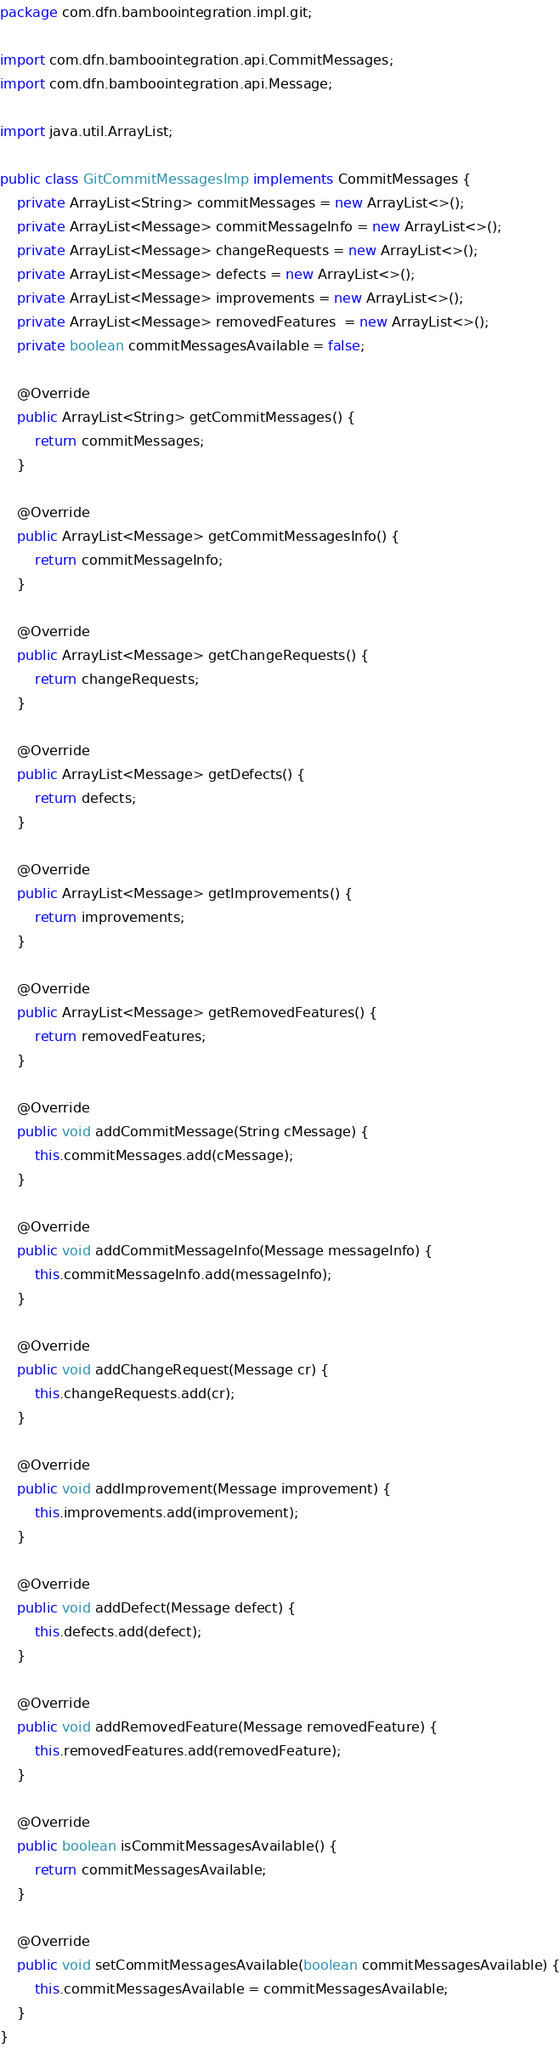Convert code to text. <code><loc_0><loc_0><loc_500><loc_500><_Java_>package com.dfn.bamboointegration.impl.git;

import com.dfn.bamboointegration.api.CommitMessages;
import com.dfn.bamboointegration.api.Message;

import java.util.ArrayList;

public class GitCommitMessagesImp implements CommitMessages {
    private ArrayList<String> commitMessages = new ArrayList<>();
    private ArrayList<Message> commitMessageInfo = new ArrayList<>();
    private ArrayList<Message> changeRequests = new ArrayList<>();
    private ArrayList<Message> defects = new ArrayList<>();
    private ArrayList<Message> improvements = new ArrayList<>();
    private ArrayList<Message> removedFeatures  = new ArrayList<>();
    private boolean commitMessagesAvailable = false;

    @Override
    public ArrayList<String> getCommitMessages() {
        return commitMessages;
    }

    @Override
    public ArrayList<Message> getCommitMessagesInfo() {
        return commitMessageInfo;
    }

    @Override
    public ArrayList<Message> getChangeRequests() {
        return changeRequests;
    }

    @Override
    public ArrayList<Message> getDefects() {
        return defects;
    }

    @Override
    public ArrayList<Message> getImprovements() {
        return improvements;
    }

    @Override
    public ArrayList<Message> getRemovedFeatures() {
        return removedFeatures;
    }

    @Override
    public void addCommitMessage(String cMessage) {
        this.commitMessages.add(cMessage);
    }

    @Override
    public void addCommitMessageInfo(Message messageInfo) {
        this.commitMessageInfo.add(messageInfo);
    }

    @Override
    public void addChangeRequest(Message cr) {
        this.changeRequests.add(cr);
    }

    @Override
    public void addImprovement(Message improvement) {
        this.improvements.add(improvement);
    }

    @Override
    public void addDefect(Message defect) {
        this.defects.add(defect);
    }

    @Override
    public void addRemovedFeature(Message removedFeature) {
        this.removedFeatures.add(removedFeature);
    }

    @Override
    public boolean isCommitMessagesAvailable() {
        return commitMessagesAvailable;
    }

    @Override
    public void setCommitMessagesAvailable(boolean commitMessagesAvailable) {
        this.commitMessagesAvailable = commitMessagesAvailable;
    }
}
</code> 